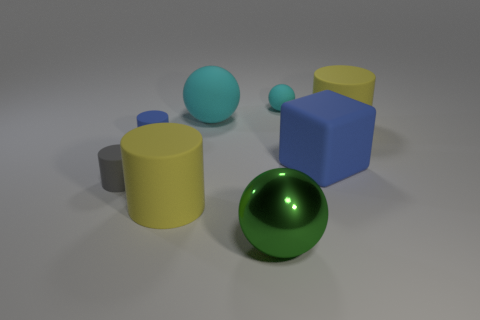Subtract all rubber spheres. How many spheres are left? 1 Subtract all blue balls. How many yellow cylinders are left? 2 Add 1 large purple things. How many objects exist? 9 Subtract 2 cylinders. How many cylinders are left? 2 Subtract all green balls. How many balls are left? 2 Subtract all cubes. How many objects are left? 7 Subtract all cyan shiny things. Subtract all green objects. How many objects are left? 7 Add 5 gray matte things. How many gray matte things are left? 6 Add 7 small rubber spheres. How many small rubber spheres exist? 8 Subtract 0 purple cylinders. How many objects are left? 8 